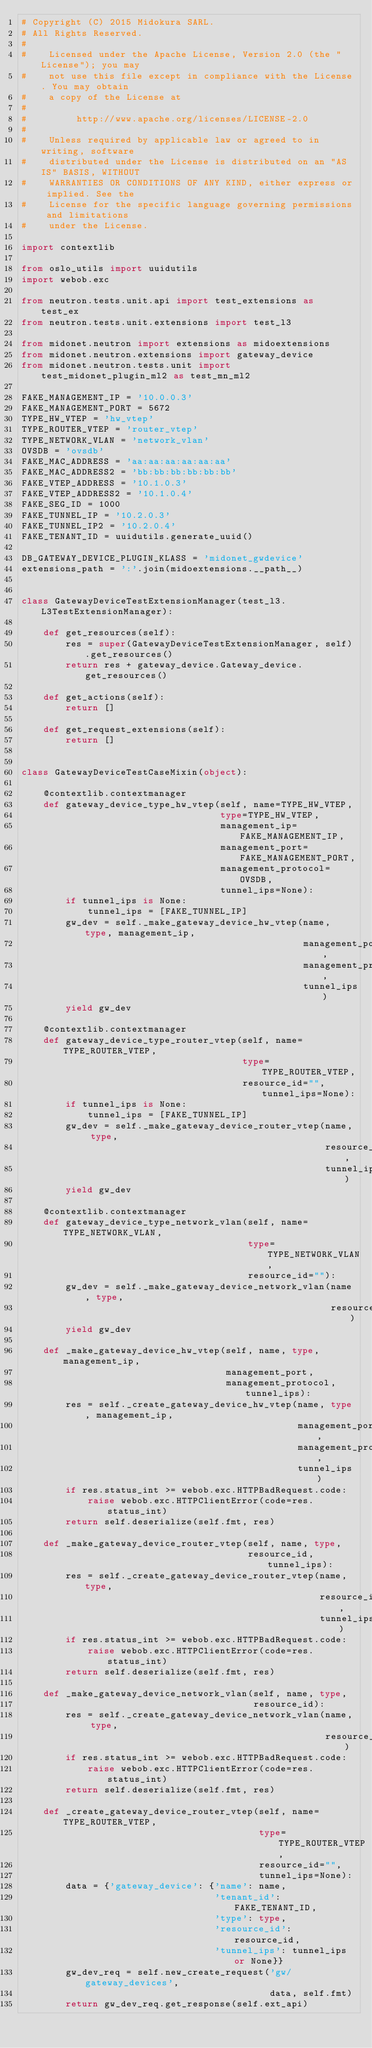<code> <loc_0><loc_0><loc_500><loc_500><_Python_># Copyright (C) 2015 Midokura SARL.
# All Rights Reserved.
#
#    Licensed under the Apache License, Version 2.0 (the "License"); you may
#    not use this file except in compliance with the License. You may obtain
#    a copy of the License at
#
#         http://www.apache.org/licenses/LICENSE-2.0
#
#    Unless required by applicable law or agreed to in writing, software
#    distributed under the License is distributed on an "AS IS" BASIS, WITHOUT
#    WARRANTIES OR CONDITIONS OF ANY KIND, either express or implied. See the
#    License for the specific language governing permissions and limitations
#    under the License.

import contextlib

from oslo_utils import uuidutils
import webob.exc

from neutron.tests.unit.api import test_extensions as test_ex
from neutron.tests.unit.extensions import test_l3

from midonet.neutron import extensions as midoextensions
from midonet.neutron.extensions import gateway_device
from midonet.neutron.tests.unit import test_midonet_plugin_ml2 as test_mn_ml2

FAKE_MANAGEMENT_IP = '10.0.0.3'
FAKE_MANAGEMENT_PORT = 5672
TYPE_HW_VTEP = 'hw_vtep'
TYPE_ROUTER_VTEP = 'router_vtep'
TYPE_NETWORK_VLAN = 'network_vlan'
OVSDB = 'ovsdb'
FAKE_MAC_ADDRESS = 'aa:aa:aa:aa:aa:aa'
FAKE_MAC_ADDRESS2 = 'bb:bb:bb:bb:bb:bb'
FAKE_VTEP_ADDRESS = '10.1.0.3'
FAKE_VTEP_ADDRESS2 = '10.1.0.4'
FAKE_SEG_ID = 1000
FAKE_TUNNEL_IP = '10.2.0.3'
FAKE_TUNNEL_IP2 = '10.2.0.4'
FAKE_TENANT_ID = uuidutils.generate_uuid()

DB_GATEWAY_DEVICE_PLUGIN_KLASS = 'midonet_gwdevice'
extensions_path = ':'.join(midoextensions.__path__)


class GatewayDeviceTestExtensionManager(test_l3.L3TestExtensionManager):

    def get_resources(self):
        res = super(GatewayDeviceTestExtensionManager, self).get_resources()
        return res + gateway_device.Gateway_device.get_resources()

    def get_actions(self):
        return []

    def get_request_extensions(self):
        return []


class GatewayDeviceTestCaseMixin(object):

    @contextlib.contextmanager
    def gateway_device_type_hw_vtep(self, name=TYPE_HW_VTEP,
                                    type=TYPE_HW_VTEP,
                                    management_ip=FAKE_MANAGEMENT_IP,
                                    management_port=FAKE_MANAGEMENT_PORT,
                                    management_protocol=OVSDB,
                                    tunnel_ips=None):
        if tunnel_ips is None:
            tunnel_ips = [FAKE_TUNNEL_IP]
        gw_dev = self._make_gateway_device_hw_vtep(name, type, management_ip,
                                                   management_port,
                                                   management_protocol,
                                                   tunnel_ips)
        yield gw_dev

    @contextlib.contextmanager
    def gateway_device_type_router_vtep(self, name=TYPE_ROUTER_VTEP,
                                        type=TYPE_ROUTER_VTEP,
                                        resource_id="", tunnel_ips=None):
        if tunnel_ips is None:
            tunnel_ips = [FAKE_TUNNEL_IP]
        gw_dev = self._make_gateway_device_router_vtep(name, type,
                                                       resource_id,
                                                       tunnel_ips)
        yield gw_dev

    @contextlib.contextmanager
    def gateway_device_type_network_vlan(self, name=TYPE_NETWORK_VLAN,
                                         type=TYPE_NETWORK_VLAN,
                                         resource_id=""):
        gw_dev = self._make_gateway_device_network_vlan(name, type,
                                                        resource_id)
        yield gw_dev

    def _make_gateway_device_hw_vtep(self, name, type, management_ip,
                                     management_port,
                                     management_protocol, tunnel_ips):
        res = self._create_gateway_device_hw_vtep(name, type, management_ip,
                                                  management_port,
                                                  management_protocol,
                                                  tunnel_ips)
        if res.status_int >= webob.exc.HTTPBadRequest.code:
            raise webob.exc.HTTPClientError(code=res.status_int)
        return self.deserialize(self.fmt, res)

    def _make_gateway_device_router_vtep(self, name, type,
                                         resource_id, tunnel_ips):
        res = self._create_gateway_device_router_vtep(name, type,
                                                      resource_id,
                                                      tunnel_ips)
        if res.status_int >= webob.exc.HTTPBadRequest.code:
            raise webob.exc.HTTPClientError(code=res.status_int)
        return self.deserialize(self.fmt, res)

    def _make_gateway_device_network_vlan(self, name, type,
                                          resource_id):
        res = self._create_gateway_device_network_vlan(name, type,
                                                       resource_id)
        if res.status_int >= webob.exc.HTTPBadRequest.code:
            raise webob.exc.HTTPClientError(code=res.status_int)
        return self.deserialize(self.fmt, res)

    def _create_gateway_device_router_vtep(self, name=TYPE_ROUTER_VTEP,
                                           type=TYPE_ROUTER_VTEP,
                                           resource_id="",
                                           tunnel_ips=None):
        data = {'gateway_device': {'name': name,
                                   'tenant_id': FAKE_TENANT_ID,
                                   'type': type,
                                   'resource_id': resource_id,
                                   'tunnel_ips': tunnel_ips or None}}
        gw_dev_req = self.new_create_request('gw/gateway_devices',
                                             data, self.fmt)
        return gw_dev_req.get_response(self.ext_api)
</code> 